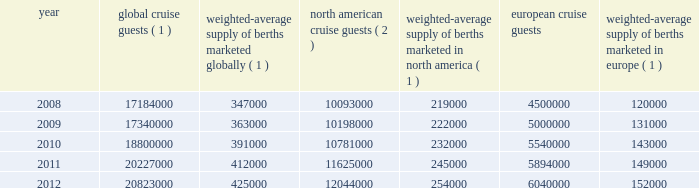Result of the effects of the costa concordia incident and the continued instability in the european eco- nomic landscape .
However , we continue to believe in the long term growth potential of this market .
We estimate that europe was served by 102 ships with approximately 108000 berths at the beginning of 2008 and by 117 ships with approximately 156000 berths at the end of 2012 .
There are approximately 9 ships with an estimated 25000 berths that are expected to be placed in service in the european cruise market between 2013 and 2017 .
The table details the growth in the global , north american and european cruise markets in terms of cruise guests and estimated weighted-average berths over the past five years : global cruise guests ( 1 ) weighted-average supply of berths marketed globally ( 1 ) north american cruise guests ( 2 ) weighted-average supply of berths marketed in north america ( 1 ) european cruise guests weighted-average supply of berths marketed in europe ( 1 ) .
( 1 ) source : our estimates of the number of global cruise guests , and the weighted-average supply of berths marketed globally , in north america and europe are based on a combination of data that we obtain from various publicly available cruise industry trade information sources including seatrade insider and cruise line international association ( 201cclia 201d ) .
In addition , our estimates incorporate our own statistical analysis utilizing the same publicly available cruise industry data as a base .
( 2 ) source : cruise line international association based on cruise guests carried for at least two consecutive nights for years 2008 through 2011 .
Year 2012 amounts represent our estimates ( see number 1 above ) .
( 3 ) source : clia europe , formerly european cruise council , for years 2008 through 2011 .
Year 2012 amounts represent our estimates ( see number 1 above ) .
Other markets in addition to expected industry growth in north america and europe as discussed above , we expect the asia/pacific region to demonstrate an even higher growth rate in the near term , although it will continue to represent a relatively small sector compared to north america and europe .
Competition we compete with a number of cruise lines .
Our princi- pal competitors are carnival corporation & plc , which owns , among others , aida cruises , carnival cruise lines , costa cruises , cunard line , holland america line , iberocruceros , p&o cruises and princess cruises ; disney cruise line ; msc cruises ; norwegian cruise line and oceania cruises .
Cruise lines compete with other vacation alternatives such as land-based resort hotels and sightseeing destinations for consumers 2019 leisure time .
Demand for such activities is influenced by political and general economic conditions .
Com- panies within the vacation market are dependent on consumer discretionary spending .
Operating strategies our principal operating strategies are to : 2022 protect the health , safety and security of our guests and employees and protect the environment in which our vessels and organization operate , 2022 strengthen and support our human capital in order to better serve our global guest base and grow our business , 2022 further strengthen our consumer engagement in order to enhance our revenues , 2022 increase the awareness and market penetration of our brands globally , 2022 focus on cost efficiency , manage our operating expenditures and ensure adequate cash and liquid- ity , with the overall goal of maximizing our return on invested capital and long-term shareholder value , 2022 strategically invest in our fleet through the revit ad alization of existing ships and the transfer of key innovations across each brand , while prudently expanding our fleet with the new state-of-the-art cruise ships recently delivered and on order , 2022 capitalize on the portability and flexibility of our ships by deploying them into those markets and itineraries that provide opportunities to optimize returns , while continuing our focus on existing key markets , 2022 further enhance our technological capabilities to service customer preferences and expectations in an innovative manner , while supporting our strategic focus on profitability , and part i 0494.indd 13 3/27/13 12:52 pm .
What was the percentage increase of the global cruise guests from 2008 to 2012? 
Computations: ((20823000 - 17184000) / 17184000)
Answer: 0.21177. 